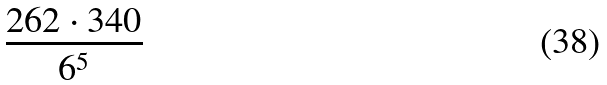Convert formula to latex. <formula><loc_0><loc_0><loc_500><loc_500>\frac { 2 6 2 \cdot 3 4 0 } { 6 ^ { 5 } }</formula> 